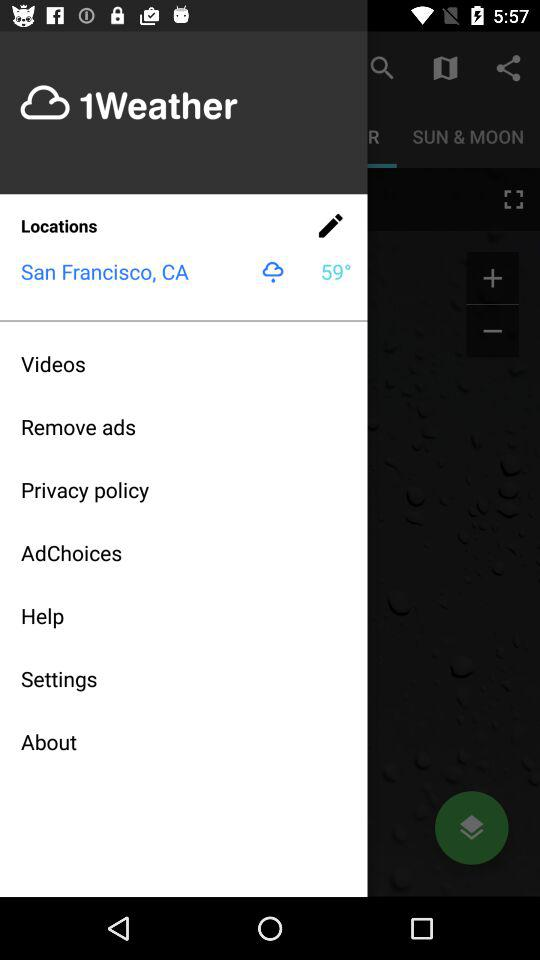What is the temperature? The temperature is 59 degrees. 